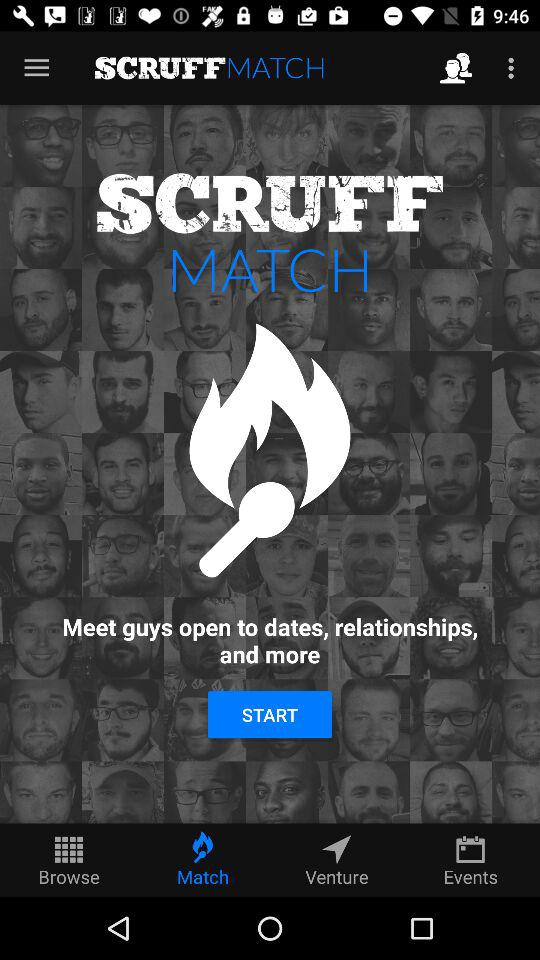What is the selected tab? The selected tab is "Match". 